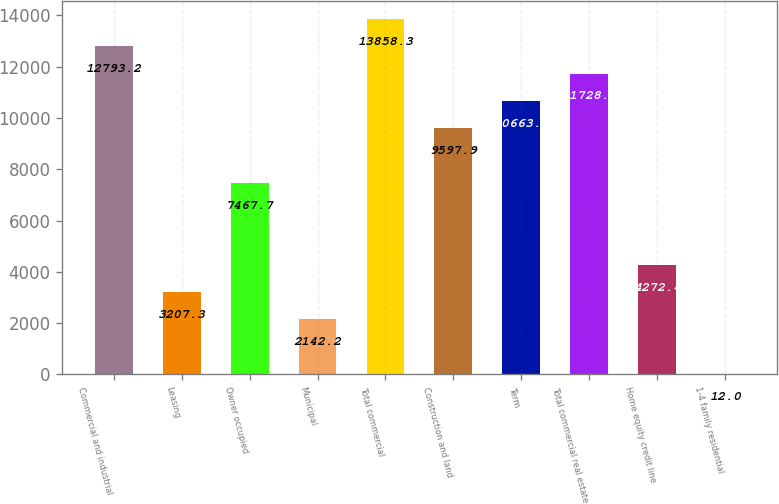Convert chart. <chart><loc_0><loc_0><loc_500><loc_500><bar_chart><fcel>Commercial and industrial<fcel>Leasing<fcel>Owner occupied<fcel>Municipal<fcel>Total commercial<fcel>Construction and land<fcel>Term<fcel>Total commercial real estate<fcel>Home equity credit line<fcel>1-4 family residential<nl><fcel>12793.2<fcel>3207.3<fcel>7467.7<fcel>2142.2<fcel>13858.3<fcel>9597.9<fcel>10663<fcel>11728.1<fcel>4272.4<fcel>12<nl></chart> 